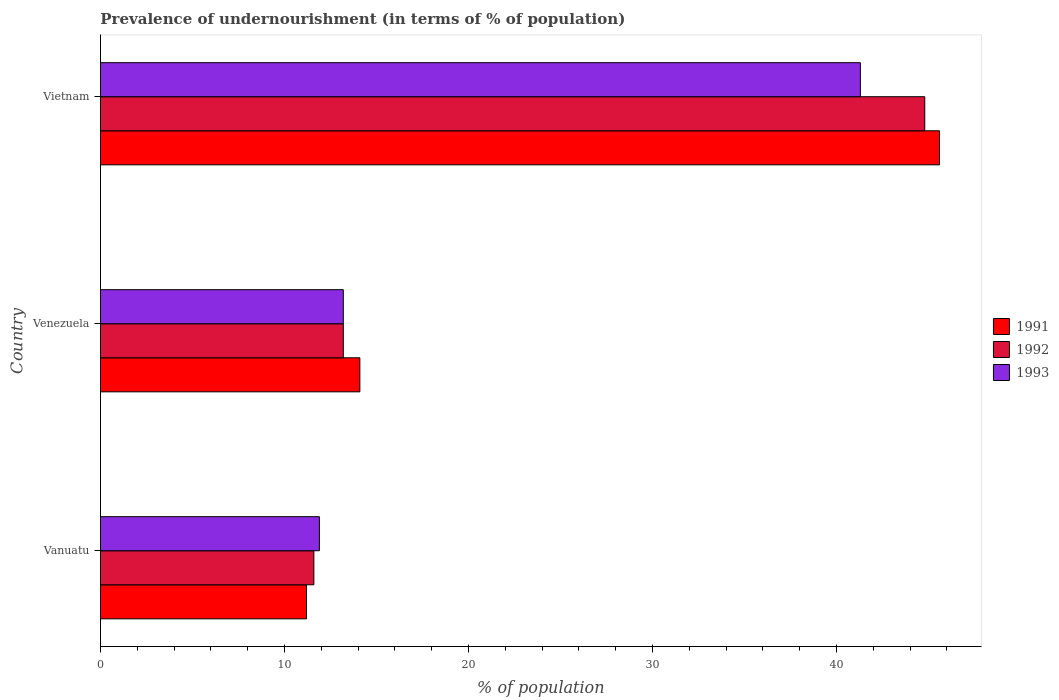What is the label of the 1st group of bars from the top?
Your answer should be compact. Vietnam. In how many cases, is the number of bars for a given country not equal to the number of legend labels?
Your answer should be compact. 0. What is the percentage of undernourished population in 1991 in Vietnam?
Offer a terse response. 45.6. Across all countries, what is the maximum percentage of undernourished population in 1991?
Your answer should be compact. 45.6. In which country was the percentage of undernourished population in 1991 maximum?
Offer a terse response. Vietnam. In which country was the percentage of undernourished population in 1992 minimum?
Offer a very short reply. Vanuatu. What is the total percentage of undernourished population in 1992 in the graph?
Ensure brevity in your answer.  69.6. What is the difference between the percentage of undernourished population in 1992 in Venezuela and that in Vietnam?
Provide a succinct answer. -31.6. What is the average percentage of undernourished population in 1992 per country?
Provide a short and direct response. 23.2. What is the difference between the percentage of undernourished population in 1993 and percentage of undernourished population in 1992 in Vietnam?
Keep it short and to the point. -3.5. In how many countries, is the percentage of undernourished population in 1991 greater than 36 %?
Provide a succinct answer. 1. What is the ratio of the percentage of undernourished population in 1991 in Vanuatu to that in Venezuela?
Provide a succinct answer. 0.79. Is the percentage of undernourished population in 1991 in Venezuela less than that in Vietnam?
Your answer should be very brief. Yes. What is the difference between the highest and the second highest percentage of undernourished population in 1993?
Ensure brevity in your answer.  28.1. What is the difference between the highest and the lowest percentage of undernourished population in 1993?
Make the answer very short. 29.4. In how many countries, is the percentage of undernourished population in 1991 greater than the average percentage of undernourished population in 1991 taken over all countries?
Keep it short and to the point. 1. Is the sum of the percentage of undernourished population in 1991 in Vanuatu and Vietnam greater than the maximum percentage of undernourished population in 1992 across all countries?
Provide a short and direct response. Yes. What does the 2nd bar from the top in Vietnam represents?
Your answer should be compact. 1992. Is it the case that in every country, the sum of the percentage of undernourished population in 1992 and percentage of undernourished population in 1991 is greater than the percentage of undernourished population in 1993?
Your answer should be compact. Yes. How many bars are there?
Your answer should be compact. 9. Are all the bars in the graph horizontal?
Provide a succinct answer. Yes. What is the difference between two consecutive major ticks on the X-axis?
Offer a very short reply. 10. Does the graph contain any zero values?
Your answer should be very brief. No. Does the graph contain grids?
Ensure brevity in your answer.  No. How are the legend labels stacked?
Provide a short and direct response. Vertical. What is the title of the graph?
Offer a terse response. Prevalence of undernourishment (in terms of % of population). Does "1987" appear as one of the legend labels in the graph?
Ensure brevity in your answer.  No. What is the label or title of the X-axis?
Keep it short and to the point. % of population. What is the % of population of 1991 in Vanuatu?
Offer a terse response. 11.2. What is the % of population of 1993 in Vanuatu?
Your response must be concise. 11.9. What is the % of population of 1991 in Venezuela?
Your answer should be very brief. 14.1. What is the % of population of 1992 in Venezuela?
Provide a short and direct response. 13.2. What is the % of population in 1991 in Vietnam?
Provide a short and direct response. 45.6. What is the % of population of 1992 in Vietnam?
Make the answer very short. 44.8. What is the % of population in 1993 in Vietnam?
Your response must be concise. 41.3. Across all countries, what is the maximum % of population of 1991?
Provide a short and direct response. 45.6. Across all countries, what is the maximum % of population in 1992?
Give a very brief answer. 44.8. Across all countries, what is the maximum % of population in 1993?
Your answer should be very brief. 41.3. Across all countries, what is the minimum % of population in 1991?
Your response must be concise. 11.2. Across all countries, what is the minimum % of population in 1993?
Give a very brief answer. 11.9. What is the total % of population of 1991 in the graph?
Keep it short and to the point. 70.9. What is the total % of population in 1992 in the graph?
Keep it short and to the point. 69.6. What is the total % of population of 1993 in the graph?
Give a very brief answer. 66.4. What is the difference between the % of population of 1991 in Vanuatu and that in Vietnam?
Offer a very short reply. -34.4. What is the difference between the % of population of 1992 in Vanuatu and that in Vietnam?
Offer a very short reply. -33.2. What is the difference between the % of population in 1993 in Vanuatu and that in Vietnam?
Give a very brief answer. -29.4. What is the difference between the % of population in 1991 in Venezuela and that in Vietnam?
Provide a succinct answer. -31.5. What is the difference between the % of population of 1992 in Venezuela and that in Vietnam?
Provide a succinct answer. -31.6. What is the difference between the % of population of 1993 in Venezuela and that in Vietnam?
Offer a very short reply. -28.1. What is the difference between the % of population in 1991 in Vanuatu and the % of population in 1992 in Venezuela?
Offer a very short reply. -2. What is the difference between the % of population in 1991 in Vanuatu and the % of population in 1993 in Venezuela?
Your answer should be compact. -2. What is the difference between the % of population in 1991 in Vanuatu and the % of population in 1992 in Vietnam?
Give a very brief answer. -33.6. What is the difference between the % of population in 1991 in Vanuatu and the % of population in 1993 in Vietnam?
Offer a terse response. -30.1. What is the difference between the % of population of 1992 in Vanuatu and the % of population of 1993 in Vietnam?
Your answer should be compact. -29.7. What is the difference between the % of population of 1991 in Venezuela and the % of population of 1992 in Vietnam?
Your response must be concise. -30.7. What is the difference between the % of population in 1991 in Venezuela and the % of population in 1993 in Vietnam?
Provide a succinct answer. -27.2. What is the difference between the % of population in 1992 in Venezuela and the % of population in 1993 in Vietnam?
Make the answer very short. -28.1. What is the average % of population in 1991 per country?
Offer a terse response. 23.63. What is the average % of population of 1992 per country?
Offer a terse response. 23.2. What is the average % of population of 1993 per country?
Make the answer very short. 22.13. What is the difference between the % of population in 1991 and % of population in 1992 in Vanuatu?
Make the answer very short. -0.4. What is the difference between the % of population of 1992 and % of population of 1993 in Vanuatu?
Offer a terse response. -0.3. What is the difference between the % of population of 1991 and % of population of 1992 in Venezuela?
Give a very brief answer. 0.9. What is the difference between the % of population of 1991 and % of population of 1993 in Venezuela?
Keep it short and to the point. 0.9. What is the difference between the % of population in 1991 and % of population in 1993 in Vietnam?
Your answer should be compact. 4.3. What is the difference between the % of population in 1992 and % of population in 1993 in Vietnam?
Your answer should be very brief. 3.5. What is the ratio of the % of population in 1991 in Vanuatu to that in Venezuela?
Your response must be concise. 0.79. What is the ratio of the % of population of 1992 in Vanuatu to that in Venezuela?
Ensure brevity in your answer.  0.88. What is the ratio of the % of population in 1993 in Vanuatu to that in Venezuela?
Make the answer very short. 0.9. What is the ratio of the % of population in 1991 in Vanuatu to that in Vietnam?
Offer a terse response. 0.25. What is the ratio of the % of population of 1992 in Vanuatu to that in Vietnam?
Your answer should be compact. 0.26. What is the ratio of the % of population of 1993 in Vanuatu to that in Vietnam?
Your answer should be very brief. 0.29. What is the ratio of the % of population of 1991 in Venezuela to that in Vietnam?
Offer a very short reply. 0.31. What is the ratio of the % of population in 1992 in Venezuela to that in Vietnam?
Make the answer very short. 0.29. What is the ratio of the % of population of 1993 in Venezuela to that in Vietnam?
Make the answer very short. 0.32. What is the difference between the highest and the second highest % of population in 1991?
Your response must be concise. 31.5. What is the difference between the highest and the second highest % of population in 1992?
Give a very brief answer. 31.6. What is the difference between the highest and the second highest % of population in 1993?
Make the answer very short. 28.1. What is the difference between the highest and the lowest % of population of 1991?
Your answer should be very brief. 34.4. What is the difference between the highest and the lowest % of population in 1992?
Your response must be concise. 33.2. What is the difference between the highest and the lowest % of population of 1993?
Keep it short and to the point. 29.4. 